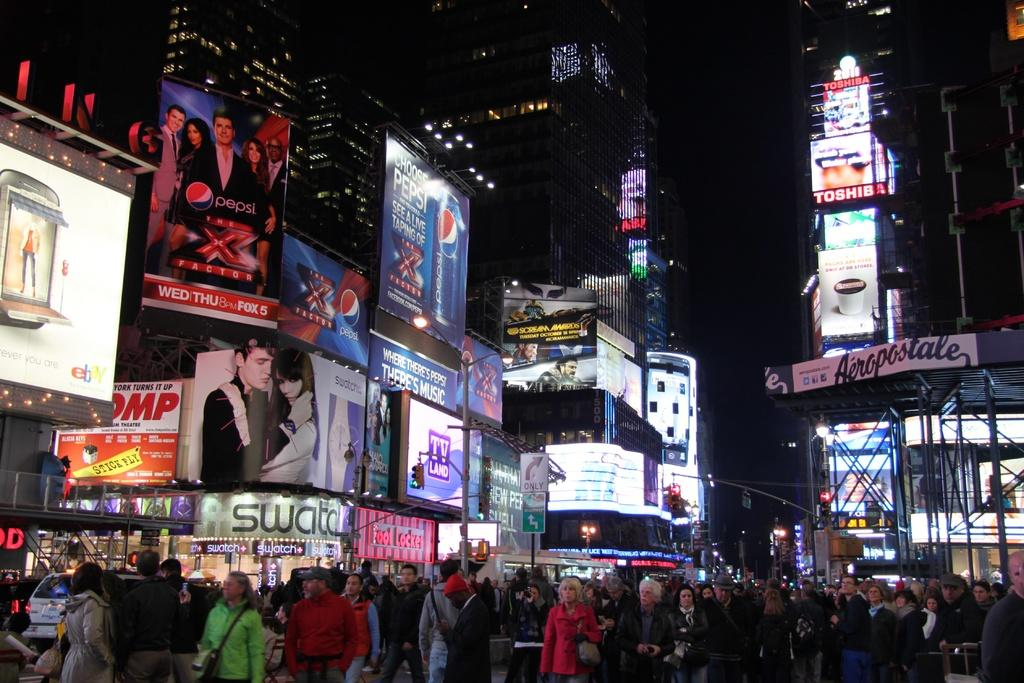<image>
Offer a succinct explanation of the picture presented. Times Square is lit up with signs for Toshiba and Pepsi as well as many others in this photo. 